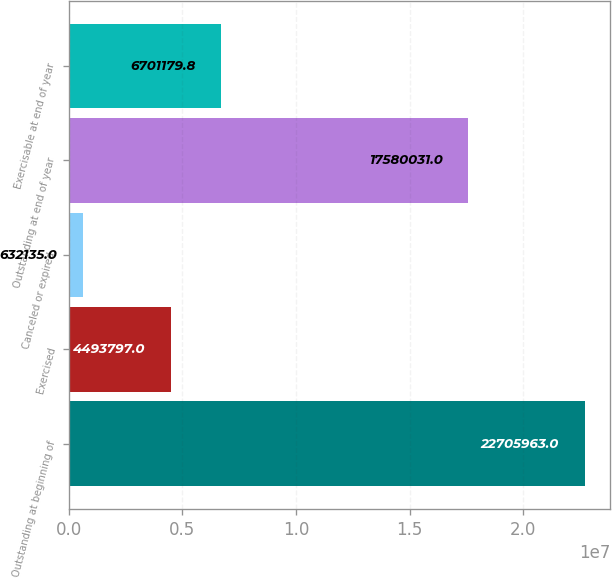Convert chart. <chart><loc_0><loc_0><loc_500><loc_500><bar_chart><fcel>Outstanding at beginning of<fcel>Exercised<fcel>Canceled or expired<fcel>Outstanding at end of year<fcel>Exercisable at end of year<nl><fcel>2.2706e+07<fcel>4.4938e+06<fcel>632135<fcel>1.758e+07<fcel>6.70118e+06<nl></chart> 